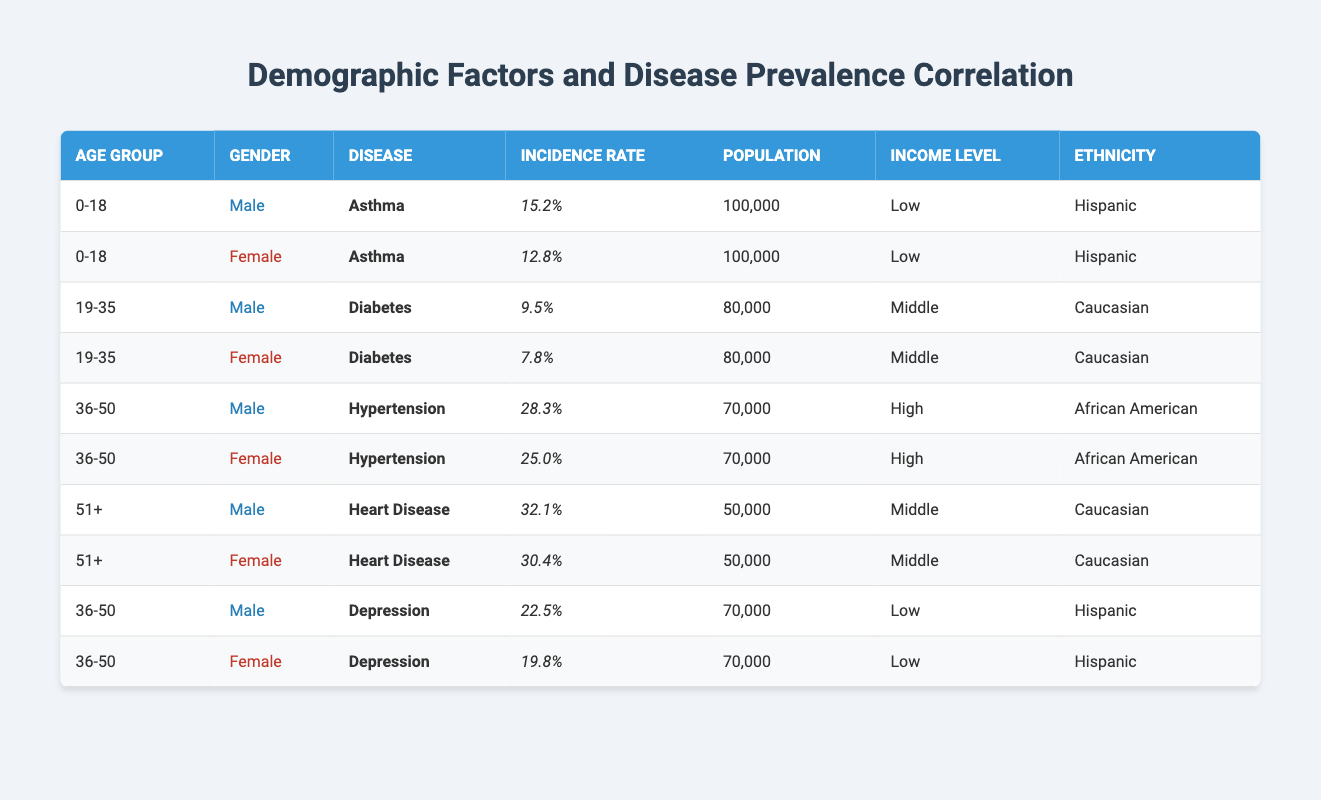What is the incidence rate of asthma among males aged 0-18? The table shows that the incidence rate for males aged 0-18 with asthma is listed as 15.2%.
Answer: 15.2% What is the total incidence rate of hypertension among both genders in the age group of 36-50? The incidence rates of hypertension for males and females aged 36-50 are 28.3% and 25.0%, respectively. Adding these gives 28.3 + 25.0 = 53.3%.
Answer: 53.3% Is the incidence rate of diabetes higher for males or females in the age group of 19-35? For males in this age group, the incidence rate of diabetes is 9.5%, while for females, it is lower at 7.8%. Thus, it is higher for males.
Answer: Yes How does the incidence rate of heart disease differ between males and females aged 51 and older? The incidence rate for males aged 51+ is 32.1%, while for females it is 30.4%. The difference is calculated as 32.1 - 30.4 = 1.7%, indicating males have a higher rate.
Answer: 1.7% What is the average incidence rate of depression among both genders in the age group of 36-50? The incidence rates of depression for males and females aged 36-50 are 22.5% and 19.8%, respectively. To find the average, we sum these rates and divide by 2: (22.5 + 19.8) / 2 = 21.15%.
Answer: 21.15% Is there any female with a higher incidence rate of asthma compared to males in the same age group? The table shows that females aged 0-18 have an asthma incidence rate of 12.8%, while males have a rate of 15.2%. So, the female incidence rate is not higher than males.
Answer: No What percentage of the population has hypertension among males in the 36-50 age group? According to the table, 28.3% of males aged 36-50 have hypertension.
Answer: 28.3% How many diseases reported have a higher incidence rate than 25% for males aged 36-50? The table shows hypertension (28.3%) and depression (22.5%) for males aged 36-50. Only hypertension is above 25%. Therefore, there is one such disease.
Answer: 1 What is the income level associated with the highest incidence rate of heart disease? The table indicates that the highest incidence rate of heart disease (32.1% for males and 30.4% for females aged 51+) is associated with the "Middle" income level.
Answer: Middle 